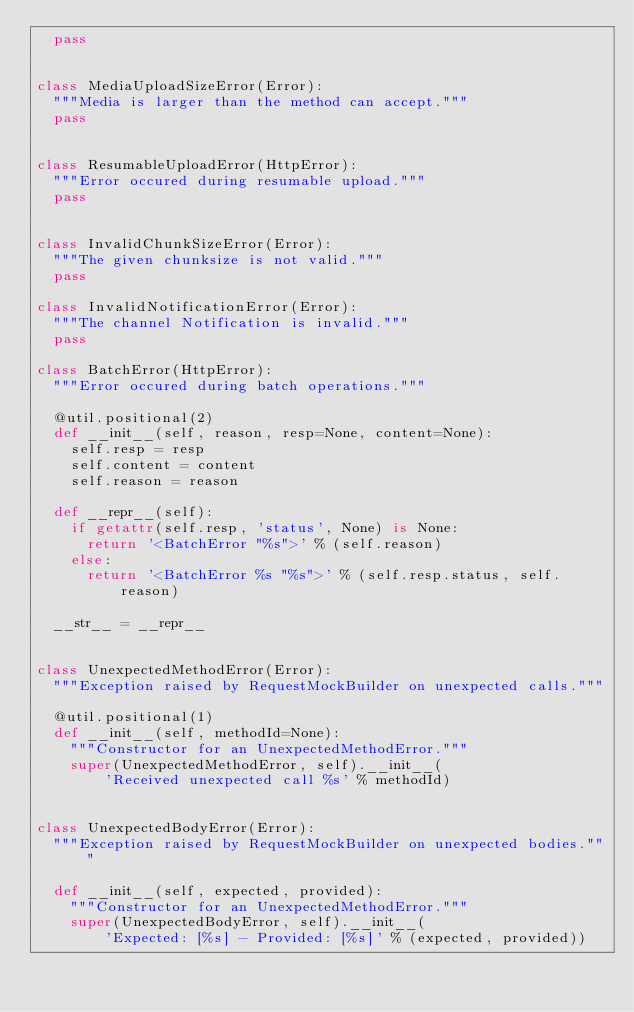<code> <loc_0><loc_0><loc_500><loc_500><_Python_>  pass


class MediaUploadSizeError(Error):
  """Media is larger than the method can accept."""
  pass


class ResumableUploadError(HttpError):
  """Error occured during resumable upload."""
  pass


class InvalidChunkSizeError(Error):
  """The given chunksize is not valid."""
  pass

class InvalidNotificationError(Error):
  """The channel Notification is invalid."""
  pass

class BatchError(HttpError):
  """Error occured during batch operations."""

  @util.positional(2)
  def __init__(self, reason, resp=None, content=None):
    self.resp = resp
    self.content = content
    self.reason = reason

  def __repr__(self):
    if getattr(self.resp, 'status', None) is None:
      return '<BatchError "%s">' % (self.reason)
    else:
      return '<BatchError %s "%s">' % (self.resp.status, self.reason)

  __str__ = __repr__


class UnexpectedMethodError(Error):
  """Exception raised by RequestMockBuilder on unexpected calls."""

  @util.positional(1)
  def __init__(self, methodId=None):
    """Constructor for an UnexpectedMethodError."""
    super(UnexpectedMethodError, self).__init__(
        'Received unexpected call %s' % methodId)


class UnexpectedBodyError(Error):
  """Exception raised by RequestMockBuilder on unexpected bodies."""

  def __init__(self, expected, provided):
    """Constructor for an UnexpectedMethodError."""
    super(UnexpectedBodyError, self).__init__(
        'Expected: [%s] - Provided: [%s]' % (expected, provided))
</code> 